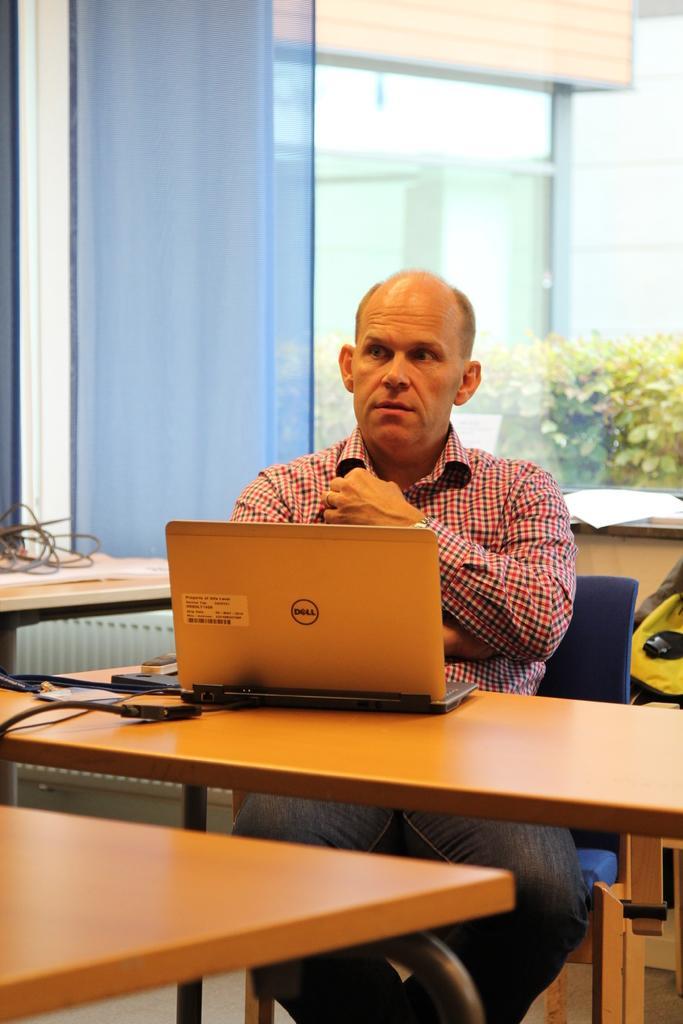Please provide a concise description of this image. In this image I can see a person sitting on the chair and he is wearing the check shirt. In front of him there is a table. On the table there is a laptop. In the back there are papers and the glass. Through the glass there are plants. 